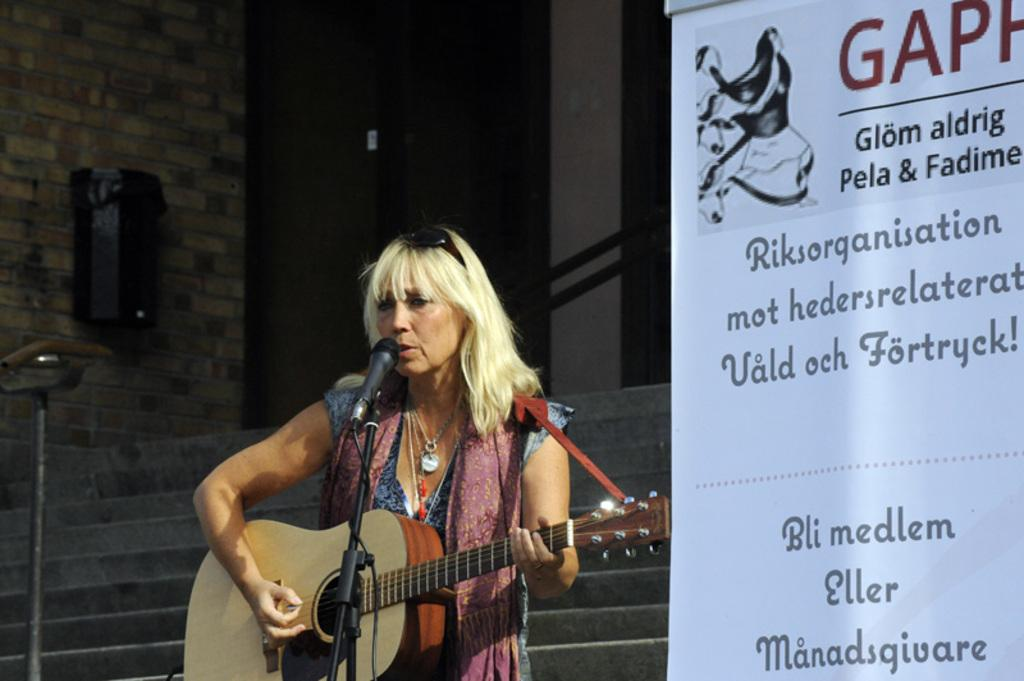What is the person in the image doing? The person is standing and holding a guitar, and they are singing. What object is the person using to amplify their voice? There is a microphone with a stand in the image. What can be seen in the background of the image? There is a wall, a speaker, and a banner in the background. What type of company is advertised on the boat in the image? There is no boat present in the image, so it is not possible to determine what type of company might be advertised on it. 